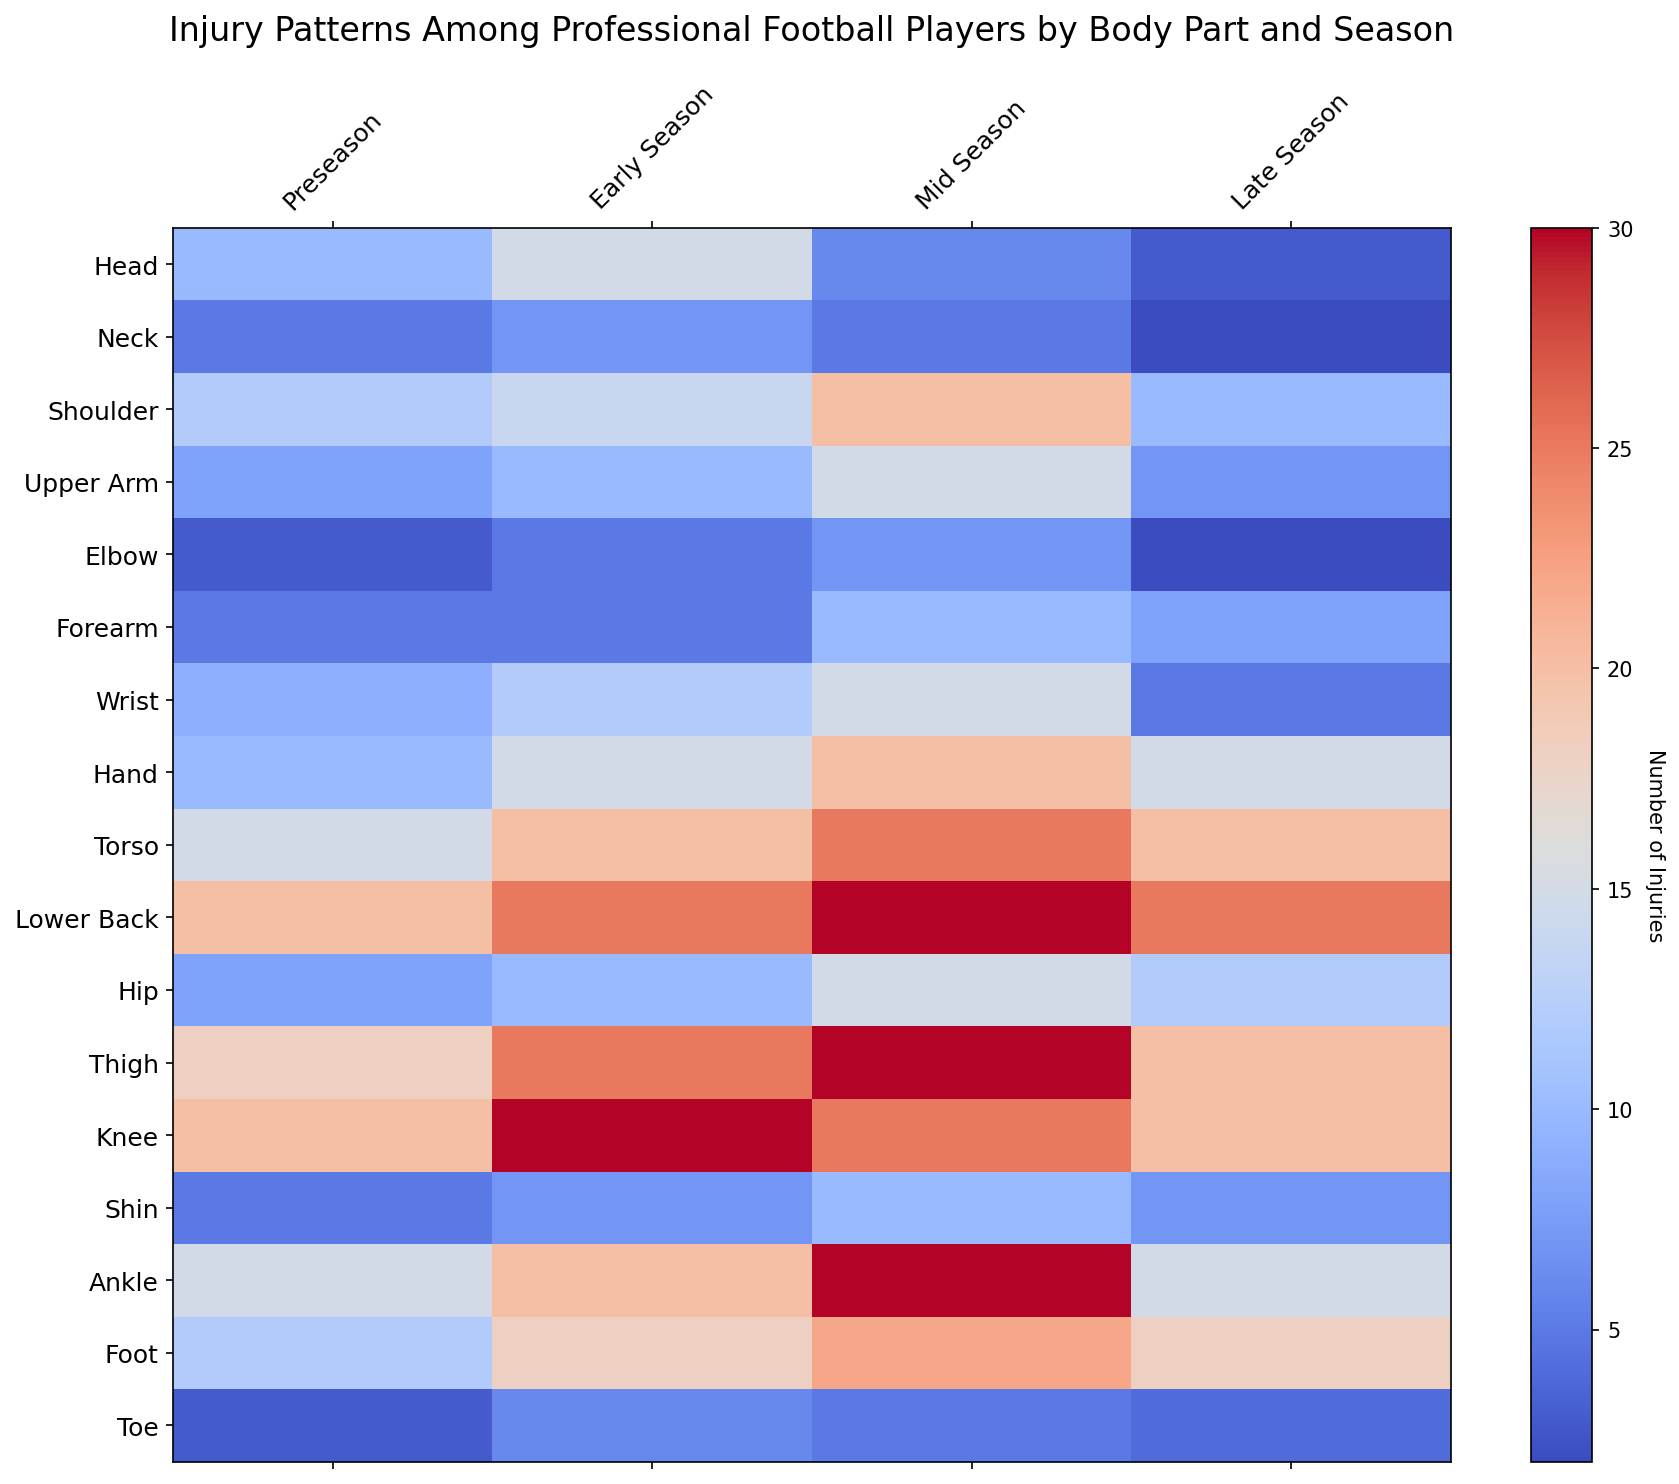Which body part has the highest number of injuries in the late season? Look at the row with the highest value in the "Late Season" column. The "Lower Back" has the highest number of injuries with a value of 25.
Answer: Lower Back Which season has the most injuries for the knee? Refer to the "Knee" row and compare the four columns. The "Early Season" has the most injuries with a value of 30.
Answer: Early Season How many total injuries occurred in the mid season for the torso and thigh combined? Add the values for "Torso" and "Thigh" in the "Mid Season" column. For "Torso" it's 25, and for "Thigh" it's 30, so 25 + 30 = 55.
Answer: 55 What is the difference between the number of shoulder injuries in the preseason and the mid season? Look at the "Shoulder" row, subtract the "Preseason" value from the "Mid Season" value. That is 20 (Mid Season) - 12 (Preseason) = 8.
Answer: 8 During which season do hand injuries reach their peak? Locate the highest value in the "Hand" row. The "Mid Season" value of 20 is the highest.
Answer: Mid Season What's the highest number of injuries for any body part during the early season? Look at the "Early Season" column and find the maximum value. The "Knee" has the highest number of injuries at 30.
Answer: Knee Compare the torso injuries between the early season and late season. Are they equal, or is one greater? Check the values in the "Torso" row for the "Early Season" and "Late Season". Both values are 20, so they are equal.
Answer: Equal Which body part has a consistent number of injuries throughout all seasons? Look for a row where the values do not change significantly. The "Forearm" has values that do not vary much: 5, 5, 10, 8.
Answer: Forearm What is the average number of injuries for the foot during the season? Sum the values for "Foot" in all four seasons and divide by 4 (12 + 18 + 22 + 18 = 70; 70 / 4 = 17.5).
Answer: 17.5 